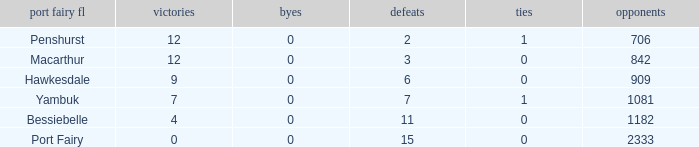How many draws when the Port Fairy FL is Hawkesdale and there are more than 9 wins? None. 